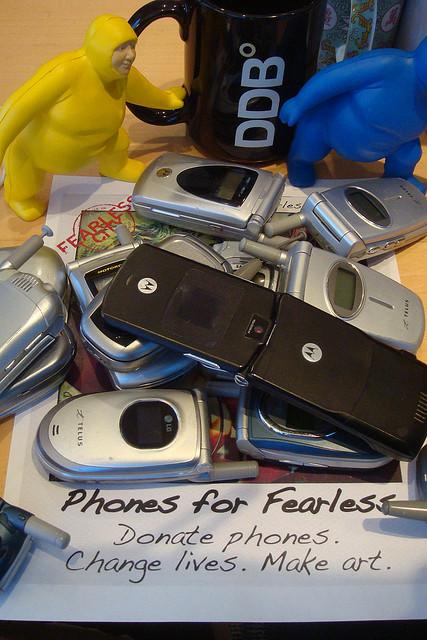How many cell phones are there?
Concise answer only. 11. What letters are on the cup?
Give a very brief answer. Ddb. How many cell phones are visible?
Quick response, please. 10. Are all these phones still working?
Concise answer only. No. 